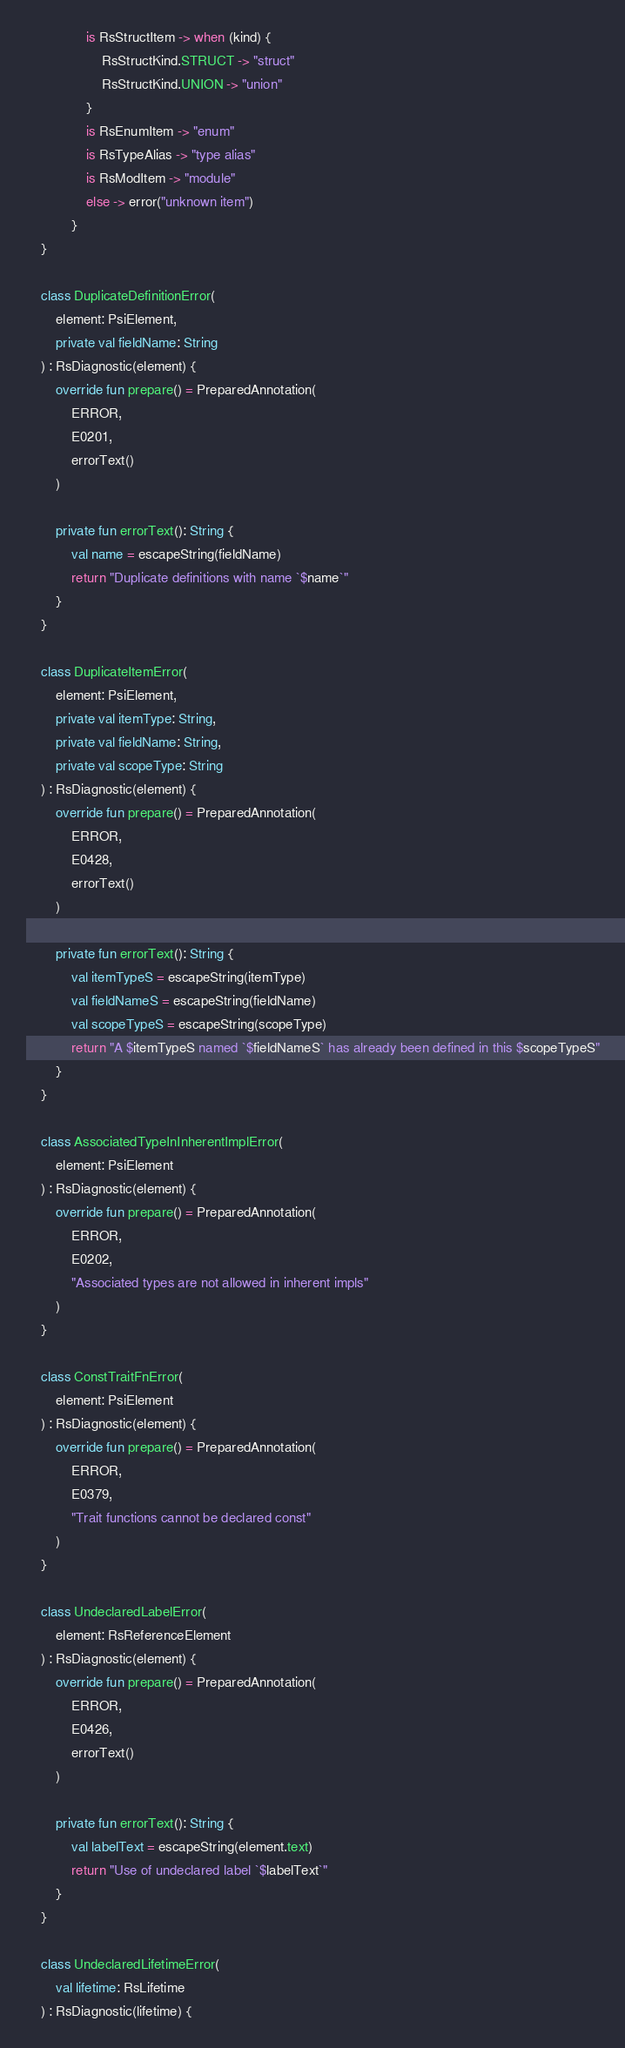Convert code to text. <code><loc_0><loc_0><loc_500><loc_500><_Kotlin_>                is RsStructItem -> when (kind) {
                    RsStructKind.STRUCT -> "struct"
                    RsStructKind.UNION -> "union"
                }
                is RsEnumItem -> "enum"
                is RsTypeAlias -> "type alias"
                is RsModItem -> "module"
                else -> error("unknown item")
            }
    }

    class DuplicateDefinitionError(
        element: PsiElement,
        private val fieldName: String
    ) : RsDiagnostic(element) {
        override fun prepare() = PreparedAnnotation(
            ERROR,
            E0201,
            errorText()
        )

        private fun errorText(): String {
            val name = escapeString(fieldName)
            return "Duplicate definitions with name `$name`"
        }
    }

    class DuplicateItemError(
        element: PsiElement,
        private val itemType: String,
        private val fieldName: String,
        private val scopeType: String
    ) : RsDiagnostic(element) {
        override fun prepare() = PreparedAnnotation(
            ERROR,
            E0428,
            errorText()
        )

        private fun errorText(): String {
            val itemTypeS = escapeString(itemType)
            val fieldNameS = escapeString(fieldName)
            val scopeTypeS = escapeString(scopeType)
            return "A $itemTypeS named `$fieldNameS` has already been defined in this $scopeTypeS"
        }
    }

    class AssociatedTypeInInherentImplError(
        element: PsiElement
    ) : RsDiagnostic(element) {
        override fun prepare() = PreparedAnnotation(
            ERROR,
            E0202,
            "Associated types are not allowed in inherent impls"
        )
    }

    class ConstTraitFnError(
        element: PsiElement
    ) : RsDiagnostic(element) {
        override fun prepare() = PreparedAnnotation(
            ERROR,
            E0379,
            "Trait functions cannot be declared const"
        )
    }

    class UndeclaredLabelError(
        element: RsReferenceElement
    ) : RsDiagnostic(element) {
        override fun prepare() = PreparedAnnotation(
            ERROR,
            E0426,
            errorText()
        )

        private fun errorText(): String {
            val labelText = escapeString(element.text)
            return "Use of undeclared label `$labelText`"
        }
    }

    class UndeclaredLifetimeError(
        val lifetime: RsLifetime
    ) : RsDiagnostic(lifetime) {</code> 